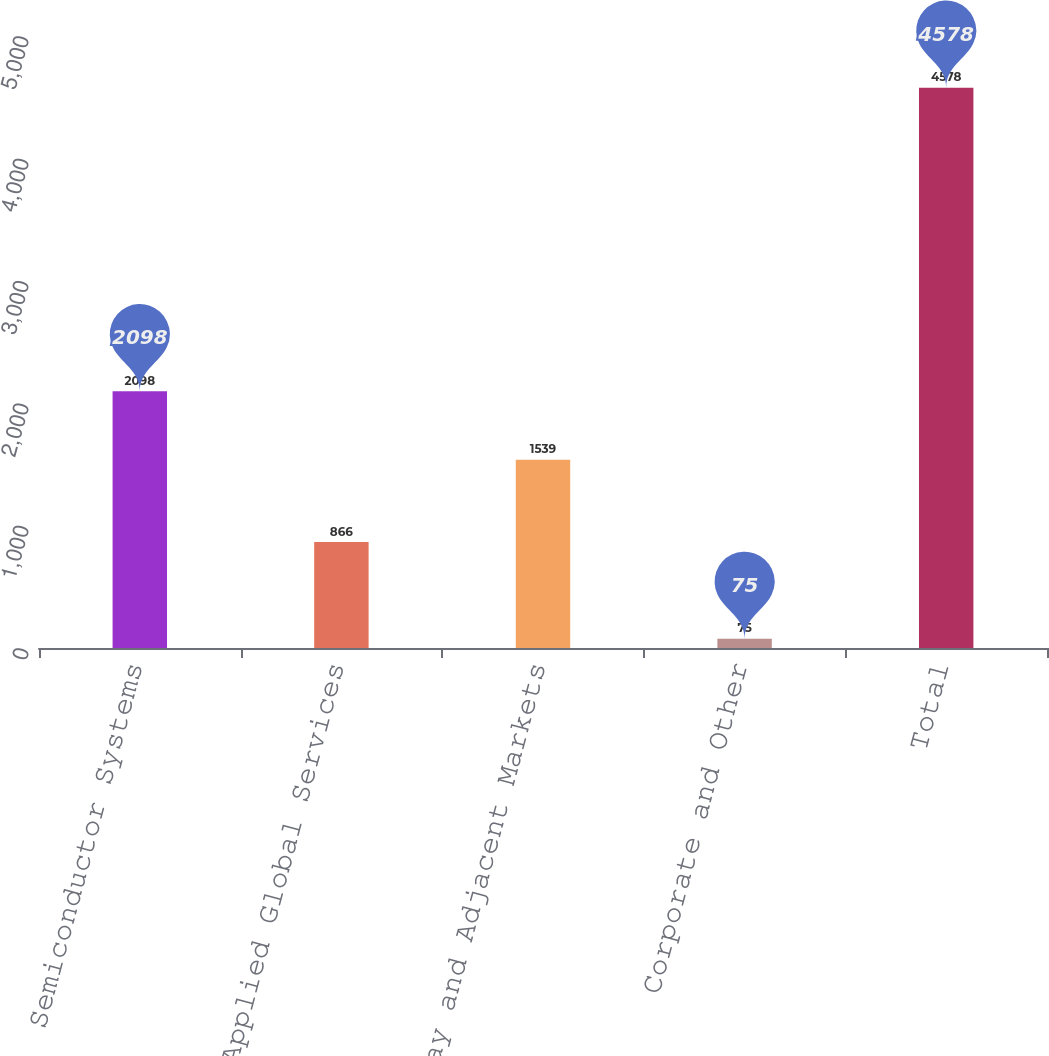Convert chart to OTSL. <chart><loc_0><loc_0><loc_500><loc_500><bar_chart><fcel>Semiconductor Systems<fcel>Applied Global Services<fcel>Display and Adjacent Markets<fcel>Corporate and Other<fcel>Total<nl><fcel>2098<fcel>866<fcel>1539<fcel>75<fcel>4578<nl></chart> 